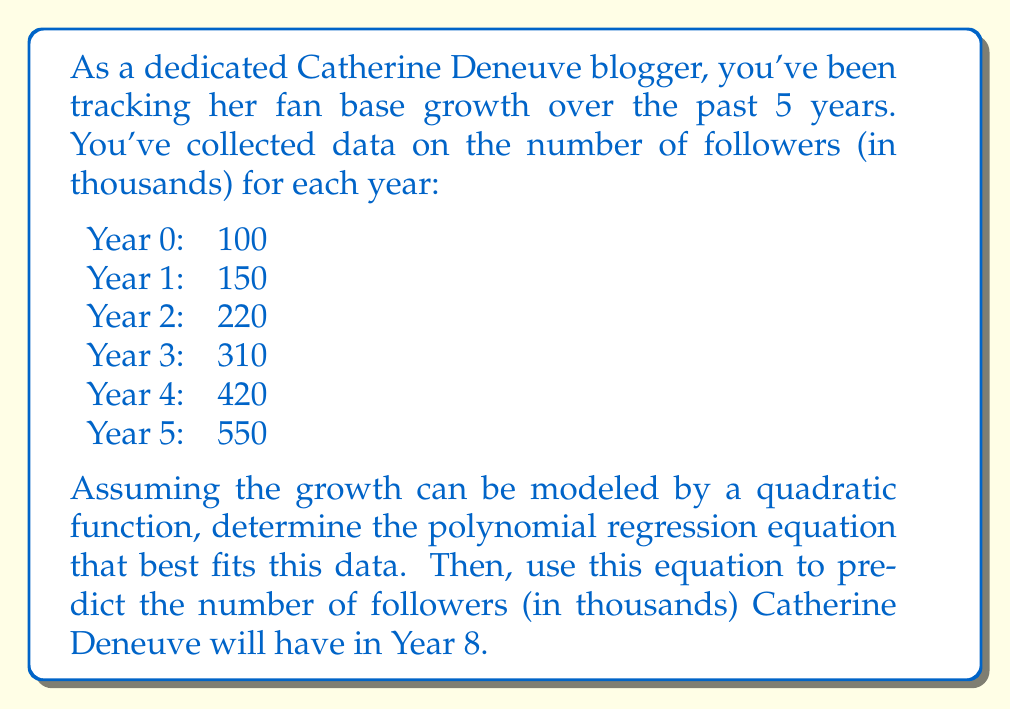What is the answer to this math problem? To find the quadratic regression equation, we'll use the form $f(x) = ax^2 + bx + c$, where $x$ represents the year and $f(x)$ represents the number of followers in thousands.

1) First, we need to set up a system of equations using the normal equations for quadratic regression:

   $$\sum y = an + b\sum x + c\sum x^2$$
   $$\sum xy = a\sum x + b\sum x^2 + c\sum x^3$$
   $$\sum x^2y = a\sum x^2 + b\sum x^3 + c\sum x^4$$

2) Calculate the sums:
   $n = 6$
   $\sum x = 0 + 1 + 2 + 3 + 4 + 5 = 15$
   $\sum x^2 = 0 + 1 + 4 + 9 + 16 + 25 = 55$
   $\sum x^3 = 0 + 1 + 8 + 27 + 64 + 125 = 225$
   $\sum x^4 = 0 + 1 + 16 + 81 + 256 + 625 = 979$
   $\sum y = 100 + 150 + 220 + 310 + 420 + 550 = 1750$
   $\sum xy = 0 + 150 + 440 + 930 + 1680 + 2750 = 5950$
   $\sum x^2y = 0 + 150 + 880 + 2790 + 6720 + 13750 = 24290$

3) Substitute these values into the normal equations:
   $$1750 = 6a + 15b + 55c$$
   $$5950 = 15a + 55b + 225c$$
   $$24290 = 55a + 225b + 979c$$

4) Solve this system of equations (using a calculator or computer algebra system):
   $a \approx 10$
   $b \approx 40$
   $c \approx 100$

5) Therefore, the quadratic regression equation is:
   $f(x) = 10x^2 + 40x + 100$

6) To predict the number of followers in Year 8, substitute $x = 8$ into this equation:
   $f(8) = 10(8)^2 + 40(8) + 100 = 10(64) + 320 + 100 = 1060$
Answer: The quadratic regression equation is $f(x) = 10x^2 + 40x + 100$, where $x$ is the number of years and $f(x)$ is the number of followers in thousands. In Year 8, Catherine Deneuve is predicted to have approximately 1,060,000 followers. 